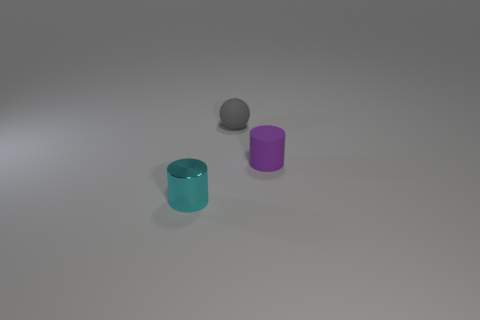Can you describe the appearance and arrangement of the objects in this image? Certainly! There are three objects resting on a flat surface. One is a teal cylindrical object with a reflective surface, the second is a purple cylindrical object that has a matte finish, and the third is a smaller grey sphere that appears metallic. The teal and purple objects are placed somewhat closely, while the grey sphere is set a little apart from them. 